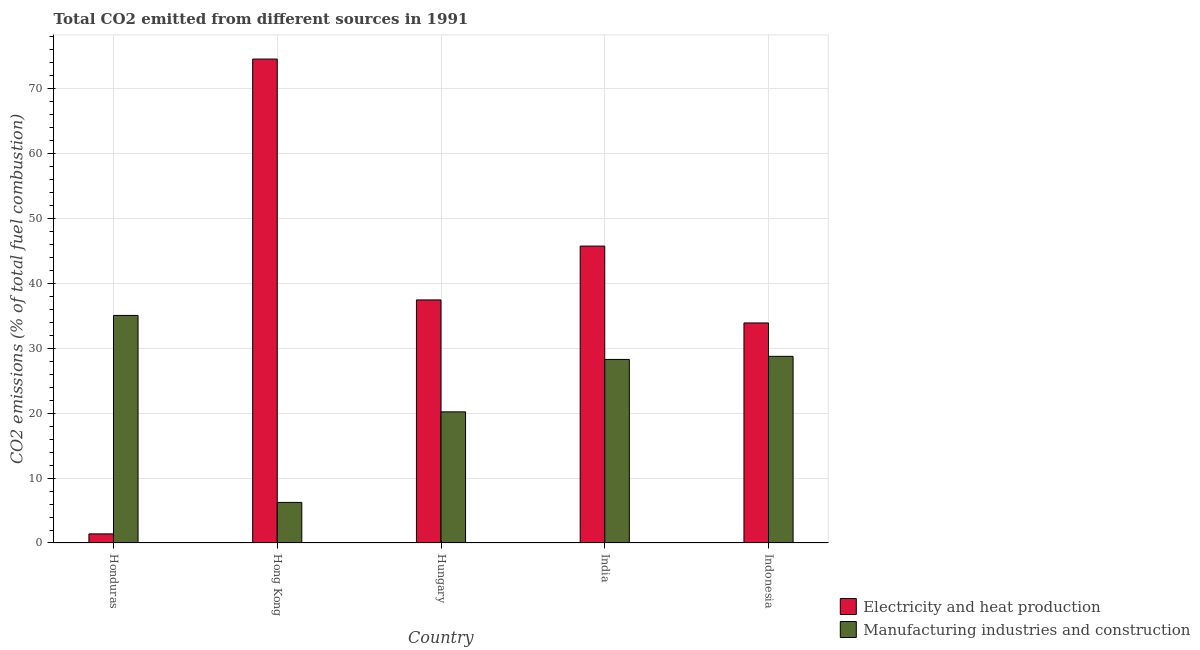How many groups of bars are there?
Ensure brevity in your answer.  5. How many bars are there on the 1st tick from the left?
Ensure brevity in your answer.  2. How many bars are there on the 3rd tick from the right?
Provide a succinct answer. 2. What is the co2 emissions due to electricity and heat production in Honduras?
Give a very brief answer. 1.4. Across all countries, what is the maximum co2 emissions due to electricity and heat production?
Make the answer very short. 74.53. Across all countries, what is the minimum co2 emissions due to electricity and heat production?
Your answer should be compact. 1.4. In which country was the co2 emissions due to electricity and heat production maximum?
Ensure brevity in your answer.  Hong Kong. In which country was the co2 emissions due to manufacturing industries minimum?
Ensure brevity in your answer.  Hong Kong. What is the total co2 emissions due to electricity and heat production in the graph?
Your answer should be compact. 192.98. What is the difference between the co2 emissions due to electricity and heat production in Hong Kong and that in Indonesia?
Keep it short and to the point. 40.64. What is the difference between the co2 emissions due to manufacturing industries in Indonesia and the co2 emissions due to electricity and heat production in Hong Kong?
Your response must be concise. -45.78. What is the average co2 emissions due to electricity and heat production per country?
Your answer should be very brief. 38.6. What is the difference between the co2 emissions due to electricity and heat production and co2 emissions due to manufacturing industries in Hungary?
Your answer should be very brief. 17.24. What is the ratio of the co2 emissions due to electricity and heat production in Hungary to that in India?
Your response must be concise. 0.82. What is the difference between the highest and the second highest co2 emissions due to electricity and heat production?
Make the answer very short. 28.8. What is the difference between the highest and the lowest co2 emissions due to electricity and heat production?
Offer a terse response. 73.13. What does the 1st bar from the left in Honduras represents?
Keep it short and to the point. Electricity and heat production. What does the 2nd bar from the right in India represents?
Keep it short and to the point. Electricity and heat production. Are all the bars in the graph horizontal?
Make the answer very short. No. How many countries are there in the graph?
Provide a short and direct response. 5. What is the difference between two consecutive major ticks on the Y-axis?
Offer a terse response. 10. Are the values on the major ticks of Y-axis written in scientific E-notation?
Offer a very short reply. No. Does the graph contain any zero values?
Keep it short and to the point. No. Does the graph contain grids?
Ensure brevity in your answer.  Yes. Where does the legend appear in the graph?
Your response must be concise. Bottom right. How are the legend labels stacked?
Make the answer very short. Vertical. What is the title of the graph?
Ensure brevity in your answer.  Total CO2 emitted from different sources in 1991. Does "Drinking water services" appear as one of the legend labels in the graph?
Your response must be concise. No. What is the label or title of the Y-axis?
Offer a terse response. CO2 emissions (% of total fuel combustion). What is the CO2 emissions (% of total fuel combustion) in Electricity and heat production in Honduras?
Provide a succinct answer. 1.4. What is the CO2 emissions (% of total fuel combustion) in Manufacturing industries and construction in Honduras?
Ensure brevity in your answer.  35.05. What is the CO2 emissions (% of total fuel combustion) in Electricity and heat production in Hong Kong?
Your response must be concise. 74.53. What is the CO2 emissions (% of total fuel combustion) in Manufacturing industries and construction in Hong Kong?
Provide a short and direct response. 6.25. What is the CO2 emissions (% of total fuel combustion) in Electricity and heat production in Hungary?
Make the answer very short. 37.43. What is the CO2 emissions (% of total fuel combustion) in Manufacturing industries and construction in Hungary?
Offer a terse response. 20.19. What is the CO2 emissions (% of total fuel combustion) in Electricity and heat production in India?
Your answer should be compact. 45.73. What is the CO2 emissions (% of total fuel combustion) in Manufacturing industries and construction in India?
Ensure brevity in your answer.  28.27. What is the CO2 emissions (% of total fuel combustion) of Electricity and heat production in Indonesia?
Make the answer very short. 33.89. What is the CO2 emissions (% of total fuel combustion) in Manufacturing industries and construction in Indonesia?
Provide a short and direct response. 28.75. Across all countries, what is the maximum CO2 emissions (% of total fuel combustion) in Electricity and heat production?
Provide a succinct answer. 74.53. Across all countries, what is the maximum CO2 emissions (% of total fuel combustion) in Manufacturing industries and construction?
Keep it short and to the point. 35.05. Across all countries, what is the minimum CO2 emissions (% of total fuel combustion) of Electricity and heat production?
Provide a succinct answer. 1.4. Across all countries, what is the minimum CO2 emissions (% of total fuel combustion) of Manufacturing industries and construction?
Your answer should be compact. 6.25. What is the total CO2 emissions (% of total fuel combustion) in Electricity and heat production in the graph?
Ensure brevity in your answer.  192.98. What is the total CO2 emissions (% of total fuel combustion) in Manufacturing industries and construction in the graph?
Your answer should be compact. 118.51. What is the difference between the CO2 emissions (% of total fuel combustion) of Electricity and heat production in Honduras and that in Hong Kong?
Offer a terse response. -73.13. What is the difference between the CO2 emissions (% of total fuel combustion) in Manufacturing industries and construction in Honduras and that in Hong Kong?
Your answer should be compact. 28.8. What is the difference between the CO2 emissions (% of total fuel combustion) of Electricity and heat production in Honduras and that in Hungary?
Provide a short and direct response. -36.03. What is the difference between the CO2 emissions (% of total fuel combustion) in Manufacturing industries and construction in Honduras and that in Hungary?
Make the answer very short. 14.85. What is the difference between the CO2 emissions (% of total fuel combustion) of Electricity and heat production in Honduras and that in India?
Your answer should be very brief. -44.32. What is the difference between the CO2 emissions (% of total fuel combustion) in Manufacturing industries and construction in Honduras and that in India?
Offer a very short reply. 6.78. What is the difference between the CO2 emissions (% of total fuel combustion) in Electricity and heat production in Honduras and that in Indonesia?
Your answer should be compact. -32.49. What is the difference between the CO2 emissions (% of total fuel combustion) in Manufacturing industries and construction in Honduras and that in Indonesia?
Your answer should be compact. 6.3. What is the difference between the CO2 emissions (% of total fuel combustion) of Electricity and heat production in Hong Kong and that in Hungary?
Make the answer very short. 37.1. What is the difference between the CO2 emissions (% of total fuel combustion) in Manufacturing industries and construction in Hong Kong and that in Hungary?
Your answer should be compact. -13.95. What is the difference between the CO2 emissions (% of total fuel combustion) in Electricity and heat production in Hong Kong and that in India?
Give a very brief answer. 28.8. What is the difference between the CO2 emissions (% of total fuel combustion) in Manufacturing industries and construction in Hong Kong and that in India?
Offer a very short reply. -22.02. What is the difference between the CO2 emissions (% of total fuel combustion) in Electricity and heat production in Hong Kong and that in Indonesia?
Your answer should be compact. 40.64. What is the difference between the CO2 emissions (% of total fuel combustion) in Manufacturing industries and construction in Hong Kong and that in Indonesia?
Offer a terse response. -22.5. What is the difference between the CO2 emissions (% of total fuel combustion) in Electricity and heat production in Hungary and that in India?
Make the answer very short. -8.29. What is the difference between the CO2 emissions (% of total fuel combustion) of Manufacturing industries and construction in Hungary and that in India?
Keep it short and to the point. -8.08. What is the difference between the CO2 emissions (% of total fuel combustion) in Electricity and heat production in Hungary and that in Indonesia?
Your response must be concise. 3.54. What is the difference between the CO2 emissions (% of total fuel combustion) in Manufacturing industries and construction in Hungary and that in Indonesia?
Your answer should be compact. -8.55. What is the difference between the CO2 emissions (% of total fuel combustion) of Electricity and heat production in India and that in Indonesia?
Ensure brevity in your answer.  11.84. What is the difference between the CO2 emissions (% of total fuel combustion) of Manufacturing industries and construction in India and that in Indonesia?
Ensure brevity in your answer.  -0.48. What is the difference between the CO2 emissions (% of total fuel combustion) in Electricity and heat production in Honduras and the CO2 emissions (% of total fuel combustion) in Manufacturing industries and construction in Hong Kong?
Ensure brevity in your answer.  -4.85. What is the difference between the CO2 emissions (% of total fuel combustion) in Electricity and heat production in Honduras and the CO2 emissions (% of total fuel combustion) in Manufacturing industries and construction in Hungary?
Your answer should be compact. -18.79. What is the difference between the CO2 emissions (% of total fuel combustion) in Electricity and heat production in Honduras and the CO2 emissions (% of total fuel combustion) in Manufacturing industries and construction in India?
Provide a succinct answer. -26.87. What is the difference between the CO2 emissions (% of total fuel combustion) of Electricity and heat production in Honduras and the CO2 emissions (% of total fuel combustion) of Manufacturing industries and construction in Indonesia?
Make the answer very short. -27.35. What is the difference between the CO2 emissions (% of total fuel combustion) of Electricity and heat production in Hong Kong and the CO2 emissions (% of total fuel combustion) of Manufacturing industries and construction in Hungary?
Give a very brief answer. 54.34. What is the difference between the CO2 emissions (% of total fuel combustion) in Electricity and heat production in Hong Kong and the CO2 emissions (% of total fuel combustion) in Manufacturing industries and construction in India?
Your answer should be very brief. 46.26. What is the difference between the CO2 emissions (% of total fuel combustion) in Electricity and heat production in Hong Kong and the CO2 emissions (% of total fuel combustion) in Manufacturing industries and construction in Indonesia?
Ensure brevity in your answer.  45.78. What is the difference between the CO2 emissions (% of total fuel combustion) in Electricity and heat production in Hungary and the CO2 emissions (% of total fuel combustion) in Manufacturing industries and construction in India?
Your answer should be very brief. 9.16. What is the difference between the CO2 emissions (% of total fuel combustion) of Electricity and heat production in Hungary and the CO2 emissions (% of total fuel combustion) of Manufacturing industries and construction in Indonesia?
Offer a very short reply. 8.69. What is the difference between the CO2 emissions (% of total fuel combustion) in Electricity and heat production in India and the CO2 emissions (% of total fuel combustion) in Manufacturing industries and construction in Indonesia?
Provide a succinct answer. 16.98. What is the average CO2 emissions (% of total fuel combustion) of Electricity and heat production per country?
Make the answer very short. 38.6. What is the average CO2 emissions (% of total fuel combustion) in Manufacturing industries and construction per country?
Your response must be concise. 23.7. What is the difference between the CO2 emissions (% of total fuel combustion) in Electricity and heat production and CO2 emissions (% of total fuel combustion) in Manufacturing industries and construction in Honduras?
Provide a succinct answer. -33.64. What is the difference between the CO2 emissions (% of total fuel combustion) in Electricity and heat production and CO2 emissions (% of total fuel combustion) in Manufacturing industries and construction in Hong Kong?
Make the answer very short. 68.28. What is the difference between the CO2 emissions (% of total fuel combustion) of Electricity and heat production and CO2 emissions (% of total fuel combustion) of Manufacturing industries and construction in Hungary?
Your answer should be very brief. 17.24. What is the difference between the CO2 emissions (% of total fuel combustion) in Electricity and heat production and CO2 emissions (% of total fuel combustion) in Manufacturing industries and construction in India?
Provide a succinct answer. 17.46. What is the difference between the CO2 emissions (% of total fuel combustion) of Electricity and heat production and CO2 emissions (% of total fuel combustion) of Manufacturing industries and construction in Indonesia?
Give a very brief answer. 5.14. What is the ratio of the CO2 emissions (% of total fuel combustion) of Electricity and heat production in Honduras to that in Hong Kong?
Make the answer very short. 0.02. What is the ratio of the CO2 emissions (% of total fuel combustion) in Manufacturing industries and construction in Honduras to that in Hong Kong?
Provide a succinct answer. 5.61. What is the ratio of the CO2 emissions (% of total fuel combustion) in Electricity and heat production in Honduras to that in Hungary?
Provide a succinct answer. 0.04. What is the ratio of the CO2 emissions (% of total fuel combustion) in Manufacturing industries and construction in Honduras to that in Hungary?
Make the answer very short. 1.74. What is the ratio of the CO2 emissions (% of total fuel combustion) in Electricity and heat production in Honduras to that in India?
Provide a short and direct response. 0.03. What is the ratio of the CO2 emissions (% of total fuel combustion) of Manufacturing industries and construction in Honduras to that in India?
Your answer should be compact. 1.24. What is the ratio of the CO2 emissions (% of total fuel combustion) of Electricity and heat production in Honduras to that in Indonesia?
Make the answer very short. 0.04. What is the ratio of the CO2 emissions (% of total fuel combustion) of Manufacturing industries and construction in Honduras to that in Indonesia?
Ensure brevity in your answer.  1.22. What is the ratio of the CO2 emissions (% of total fuel combustion) of Electricity and heat production in Hong Kong to that in Hungary?
Your response must be concise. 1.99. What is the ratio of the CO2 emissions (% of total fuel combustion) in Manufacturing industries and construction in Hong Kong to that in Hungary?
Offer a terse response. 0.31. What is the ratio of the CO2 emissions (% of total fuel combustion) of Electricity and heat production in Hong Kong to that in India?
Offer a very short reply. 1.63. What is the ratio of the CO2 emissions (% of total fuel combustion) in Manufacturing industries and construction in Hong Kong to that in India?
Offer a very short reply. 0.22. What is the ratio of the CO2 emissions (% of total fuel combustion) in Electricity and heat production in Hong Kong to that in Indonesia?
Make the answer very short. 2.2. What is the ratio of the CO2 emissions (% of total fuel combustion) of Manufacturing industries and construction in Hong Kong to that in Indonesia?
Your answer should be very brief. 0.22. What is the ratio of the CO2 emissions (% of total fuel combustion) of Electricity and heat production in Hungary to that in India?
Offer a very short reply. 0.82. What is the ratio of the CO2 emissions (% of total fuel combustion) in Manufacturing industries and construction in Hungary to that in India?
Your response must be concise. 0.71. What is the ratio of the CO2 emissions (% of total fuel combustion) of Electricity and heat production in Hungary to that in Indonesia?
Provide a short and direct response. 1.1. What is the ratio of the CO2 emissions (% of total fuel combustion) of Manufacturing industries and construction in Hungary to that in Indonesia?
Your response must be concise. 0.7. What is the ratio of the CO2 emissions (% of total fuel combustion) in Electricity and heat production in India to that in Indonesia?
Give a very brief answer. 1.35. What is the ratio of the CO2 emissions (% of total fuel combustion) in Manufacturing industries and construction in India to that in Indonesia?
Your response must be concise. 0.98. What is the difference between the highest and the second highest CO2 emissions (% of total fuel combustion) of Electricity and heat production?
Offer a terse response. 28.8. What is the difference between the highest and the second highest CO2 emissions (% of total fuel combustion) of Manufacturing industries and construction?
Provide a short and direct response. 6.3. What is the difference between the highest and the lowest CO2 emissions (% of total fuel combustion) of Electricity and heat production?
Provide a succinct answer. 73.13. What is the difference between the highest and the lowest CO2 emissions (% of total fuel combustion) of Manufacturing industries and construction?
Provide a succinct answer. 28.8. 